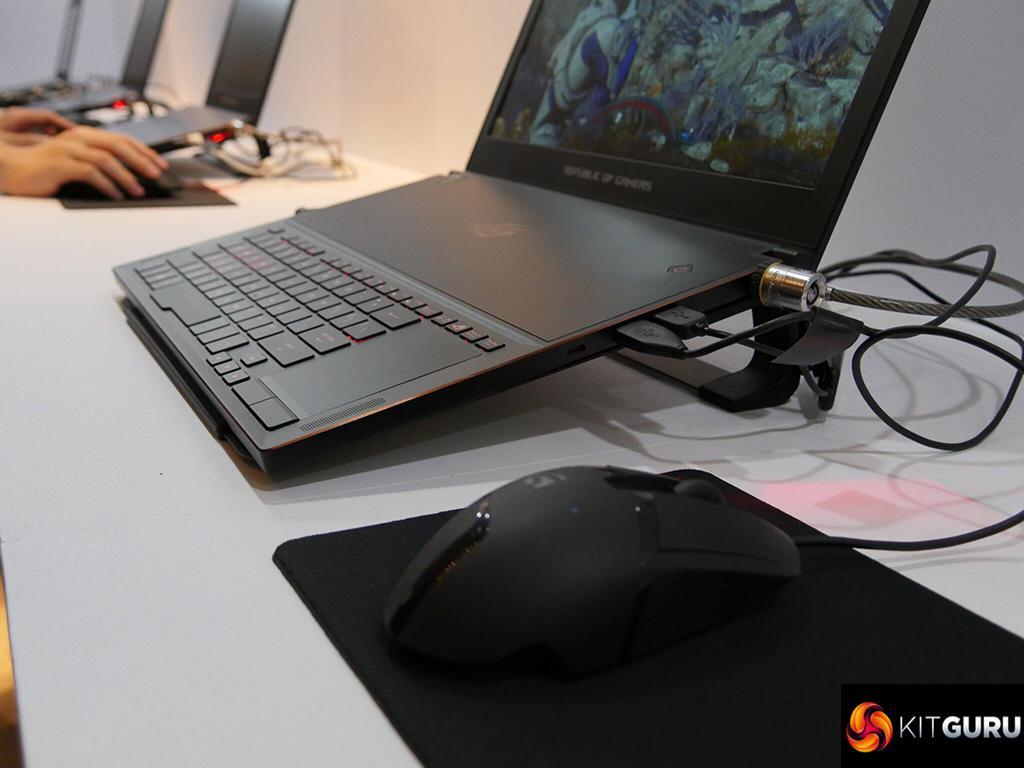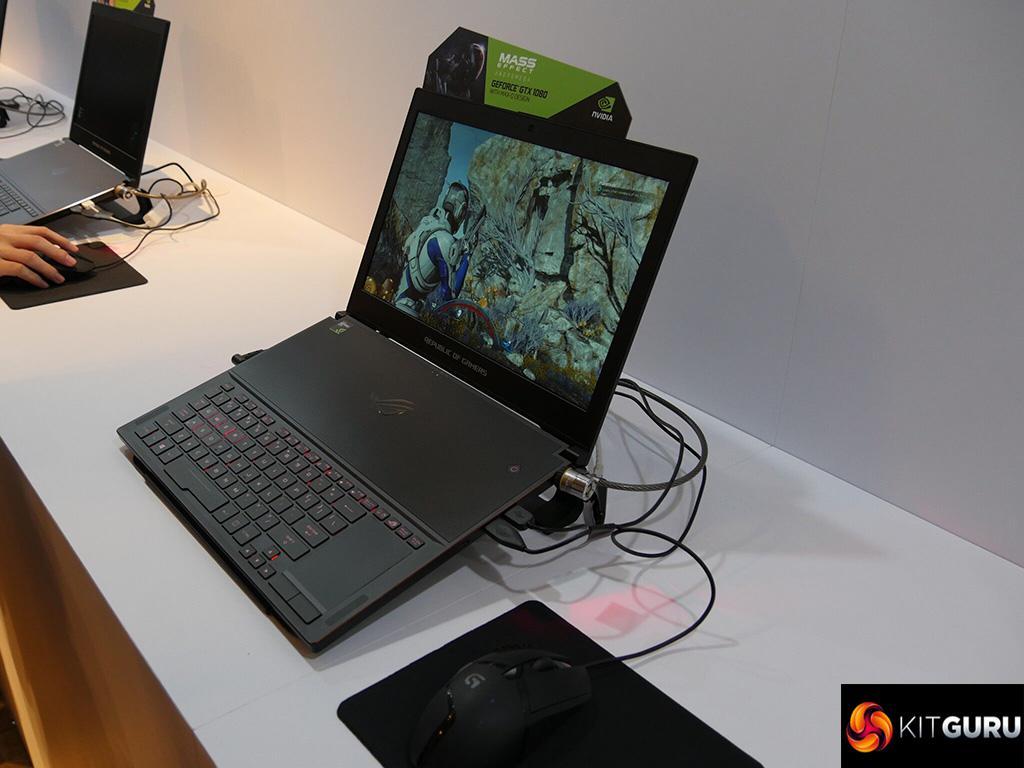The first image is the image on the left, the second image is the image on the right. For the images displayed, is the sentence "Wires are coming out the right side of the computer in at least one of the images." factually correct? Answer yes or no. Yes. The first image is the image on the left, the second image is the image on the right. For the images displayed, is the sentence "there is a laptop sitting on a wooden table" factually correct? Answer yes or no. No. 